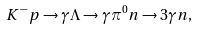<formula> <loc_0><loc_0><loc_500><loc_500>K ^ { - } p \to \gamma \Lambda \to \gamma \pi ^ { 0 } n \to 3 \gamma n ,</formula> 